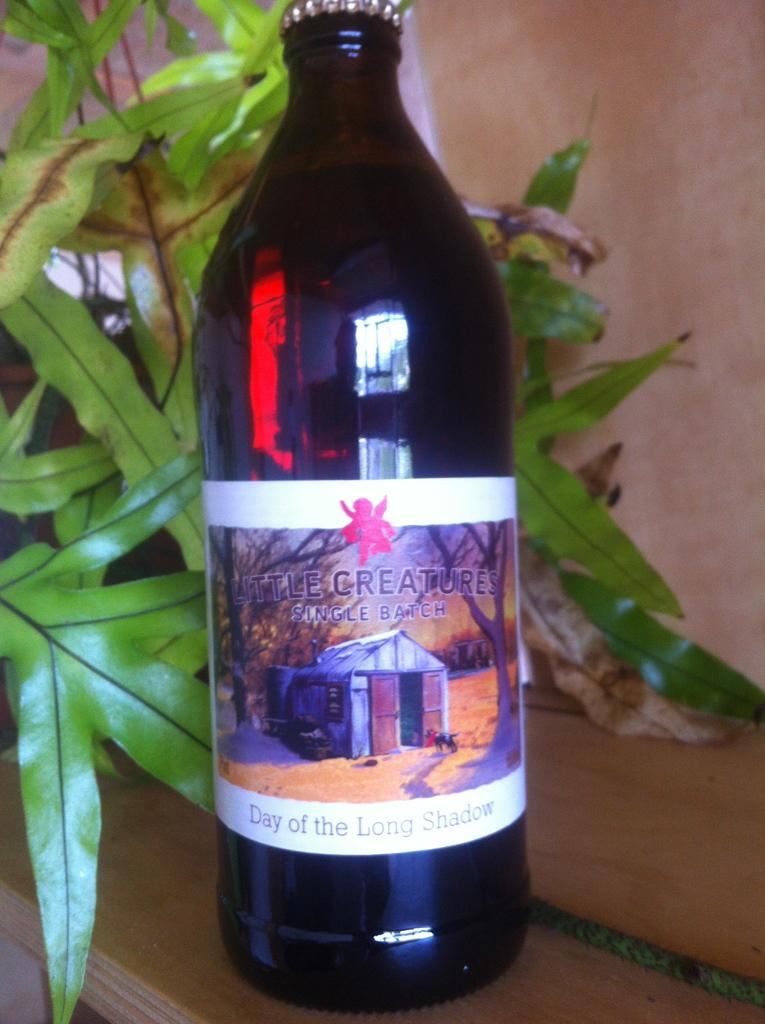What is the color of the wall in the image? The wall in the image is pink. What other objects can be seen in the image? There is a plant and a black color bottle in the image. What is written on the bottle? The bottle has the words "little creatures" written on it. How many times does the coach sneeze in the image? There is no coach or sneezing in the image. What type of rose is growing on the plant in the image? There is no rose present in the image; it is a plant without any specific type of flower mentioned. 